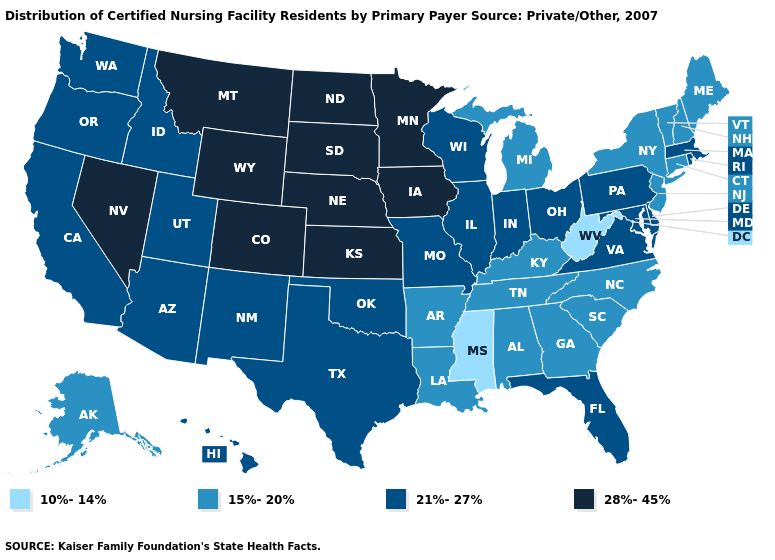Name the states that have a value in the range 10%-14%?
Quick response, please. Mississippi, West Virginia. Does Louisiana have a higher value than Oklahoma?
Give a very brief answer. No. What is the value of Iowa?
Quick response, please. 28%-45%. What is the value of Nebraska?
Answer briefly. 28%-45%. Does Kansas have the highest value in the USA?
Give a very brief answer. Yes. What is the highest value in the USA?
Be succinct. 28%-45%. Does New Mexico have a lower value than Wisconsin?
Answer briefly. No. What is the value of Massachusetts?
Short answer required. 21%-27%. What is the value of Idaho?
Give a very brief answer. 21%-27%. Name the states that have a value in the range 21%-27%?
Be succinct. Arizona, California, Delaware, Florida, Hawaii, Idaho, Illinois, Indiana, Maryland, Massachusetts, Missouri, New Mexico, Ohio, Oklahoma, Oregon, Pennsylvania, Rhode Island, Texas, Utah, Virginia, Washington, Wisconsin. Does the map have missing data?
Give a very brief answer. No. Which states hav the highest value in the South?
Be succinct. Delaware, Florida, Maryland, Oklahoma, Texas, Virginia. Which states hav the highest value in the South?
Give a very brief answer. Delaware, Florida, Maryland, Oklahoma, Texas, Virginia. Name the states that have a value in the range 28%-45%?
Quick response, please. Colorado, Iowa, Kansas, Minnesota, Montana, Nebraska, Nevada, North Dakota, South Dakota, Wyoming. 